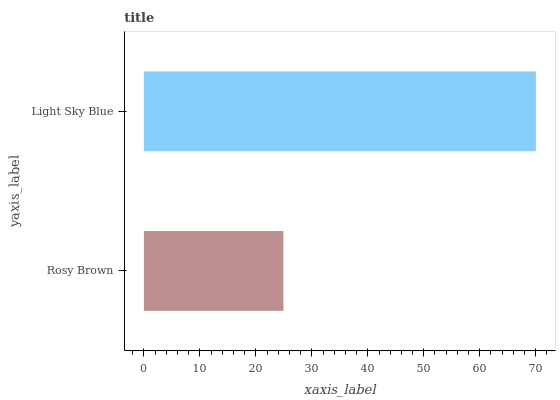Is Rosy Brown the minimum?
Answer yes or no. Yes. Is Light Sky Blue the maximum?
Answer yes or no. Yes. Is Light Sky Blue the minimum?
Answer yes or no. No. Is Light Sky Blue greater than Rosy Brown?
Answer yes or no. Yes. Is Rosy Brown less than Light Sky Blue?
Answer yes or no. Yes. Is Rosy Brown greater than Light Sky Blue?
Answer yes or no. No. Is Light Sky Blue less than Rosy Brown?
Answer yes or no. No. Is Light Sky Blue the high median?
Answer yes or no. Yes. Is Rosy Brown the low median?
Answer yes or no. Yes. Is Rosy Brown the high median?
Answer yes or no. No. Is Light Sky Blue the low median?
Answer yes or no. No. 